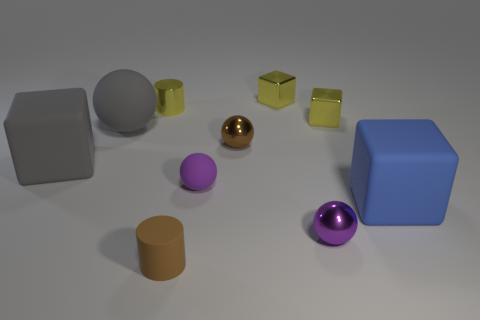Subtract all gray cubes. How many cubes are left? 3 Subtract 2 balls. How many balls are left? 2 Subtract all cyan blocks. Subtract all cyan cylinders. How many blocks are left? 4 Subtract all cylinders. How many objects are left? 8 Subtract 1 brown cylinders. How many objects are left? 9 Subtract all small matte cylinders. Subtract all brown rubber cylinders. How many objects are left? 8 Add 1 metallic blocks. How many metallic blocks are left? 3 Add 2 tiny blue rubber balls. How many tiny blue rubber balls exist? 2 